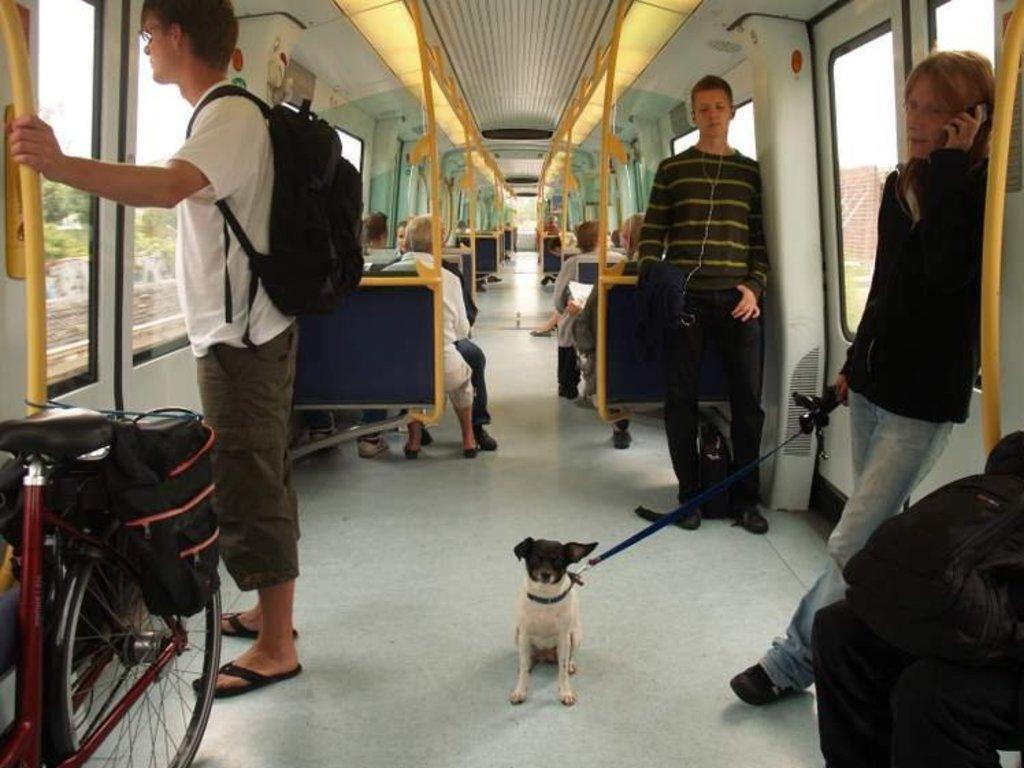What type of vehicle is shown in the image? The image shows the interior of a train. What are the people in the train doing? There are people sitting and standing in the train. Are there any animals present in the image? Yes, there is a dog in the train. What other objects can be seen in the train? There is a bicycle and an emergency alarm in the train. What type of haircut is the dog getting in the image? There is no haircut being performed in the image; the dog is simply present in the train. Is the train interior decorated with quartz in the image? There is no mention of quartz or any specific decorations in the image; it shows the general interior of a train. 